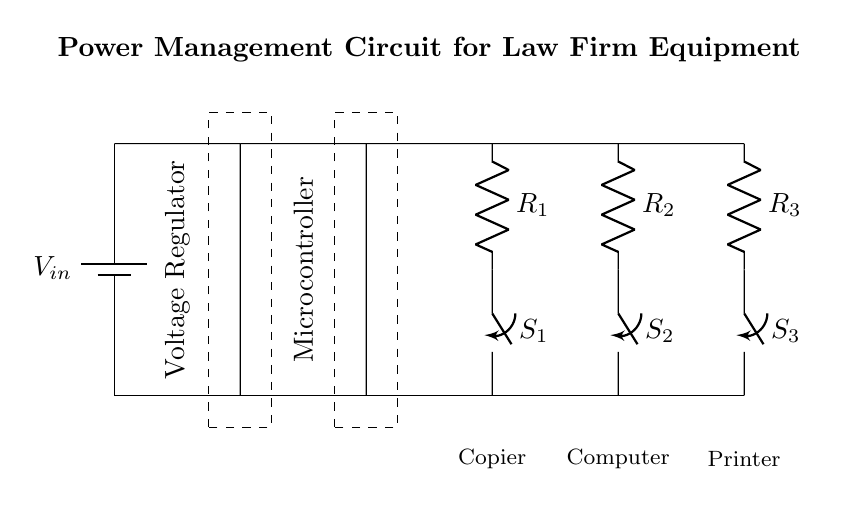What is the primary power source in this circuit? The primary power source is indicated as a battery symbol labeled V_in, which provides the required voltage to the circuit.
Answer: battery What is the purpose of the voltage regulator? The voltage regulator is represented in the dashed rectangle and is used to maintain a consistent output voltage level from the varying input voltage, ensuring that downstream components receive the correct voltage.
Answer: consistent output voltage How many resistors are present in the circuit? There are three resistors labeled R_1, R_2, and R_3, connected in parallel to distribute power to different components in the circuit.
Answer: three What components are being powered by the circuit? The circuit powers three components indicated by labels: Copier, Computer, and Printer, each with its associated switch and resistor.
Answer: Copier, Computer, Printer What does switch S_1 control? Switch S_1 is labeled in the circuit and controls the power path to the resistor R_1, which is connected to the Copier, thus allowing on/off control of the Copier power.
Answer: Copier If all switches are closed, what will happen to the overall resistance? When all switches are closed, the resistors R_1, R_2, and R_3 will be in parallel, and the overall resistance will decrease due to the parallel combination formula, allowing more current to flow through the circuit.
Answer: decrease What type of circuit is represented in this diagram? The circuit is a power management circuit designed specifically for controlling and distributing power efficiently to office equipment, making it suitable for energy efficiency in a law firm context.
Answer: power management circuit 